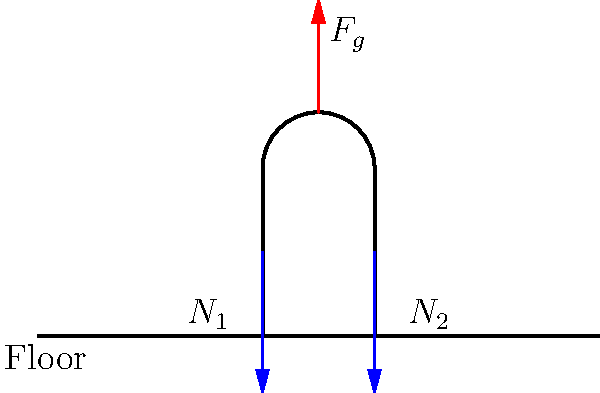During a prolonged prayer session, a disciple kneels on the floor as shown in the diagram. The disciple's weight is 70 kg, and the gravitational acceleration is 9.8 m/s². Assuming the weight is evenly distributed between both knees, what is the magnitude of the normal force ($N_1$ or $N_2$) acting on each knee? To solve this problem, we'll follow these steps:

1. Identify the forces acting on the kneeling disciple:
   - Gravitational force ($F_g$) acting downward
   - Normal forces ($N_1$ and $N_2$) acting upward at each knee

2. Calculate the gravitational force:
   $F_g = m \times g$
   $F_g = 70 \text{ kg} \times 9.8 \text{ m/s}^2 = 686 \text{ N}$

3. Apply Newton's Second Law for equilibrium:
   In the vertical direction, the sum of forces must equal zero:
   $\sum F_y = 0$
   $N_1 + N_2 - F_g = 0$

4. Given that the weight is evenly distributed between both knees:
   $N_1 = N_2 = \frac{F_g}{2}$

5. Calculate the magnitude of the normal force on each knee:
   $N_1 = N_2 = \frac{686 \text{ N}}{2} = 343 \text{ N}$

Therefore, the magnitude of the normal force acting on each knee is 343 N.
Answer: 343 N 